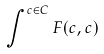Convert formula to latex. <formula><loc_0><loc_0><loc_500><loc_500>\int ^ { c \in C } F ( c , c )</formula> 